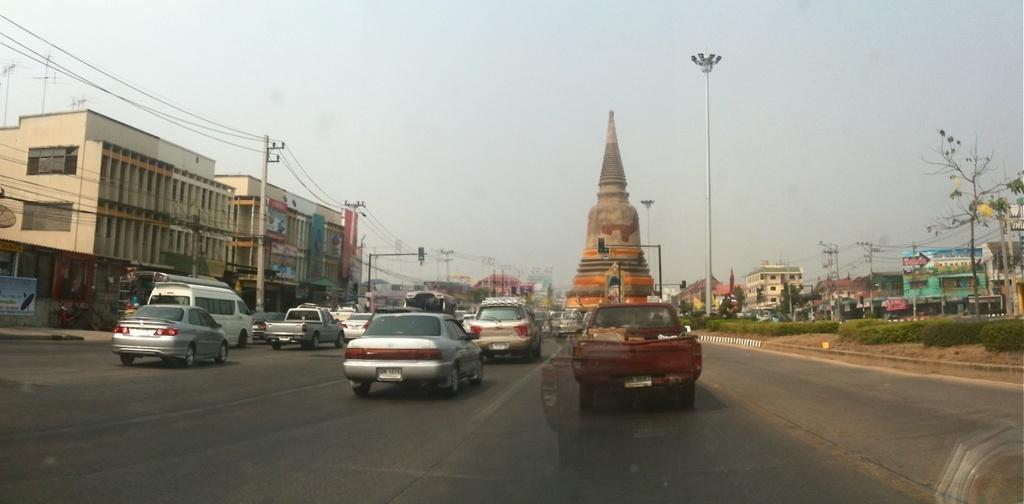How would you summarize this image in a sentence or two? In this image in the center there are vehicles moving on the road. On the left side there are buildings, poles, and there are wires attached to the poles. On the right side there are buildings, plants, poles and the sky is cloudy. 